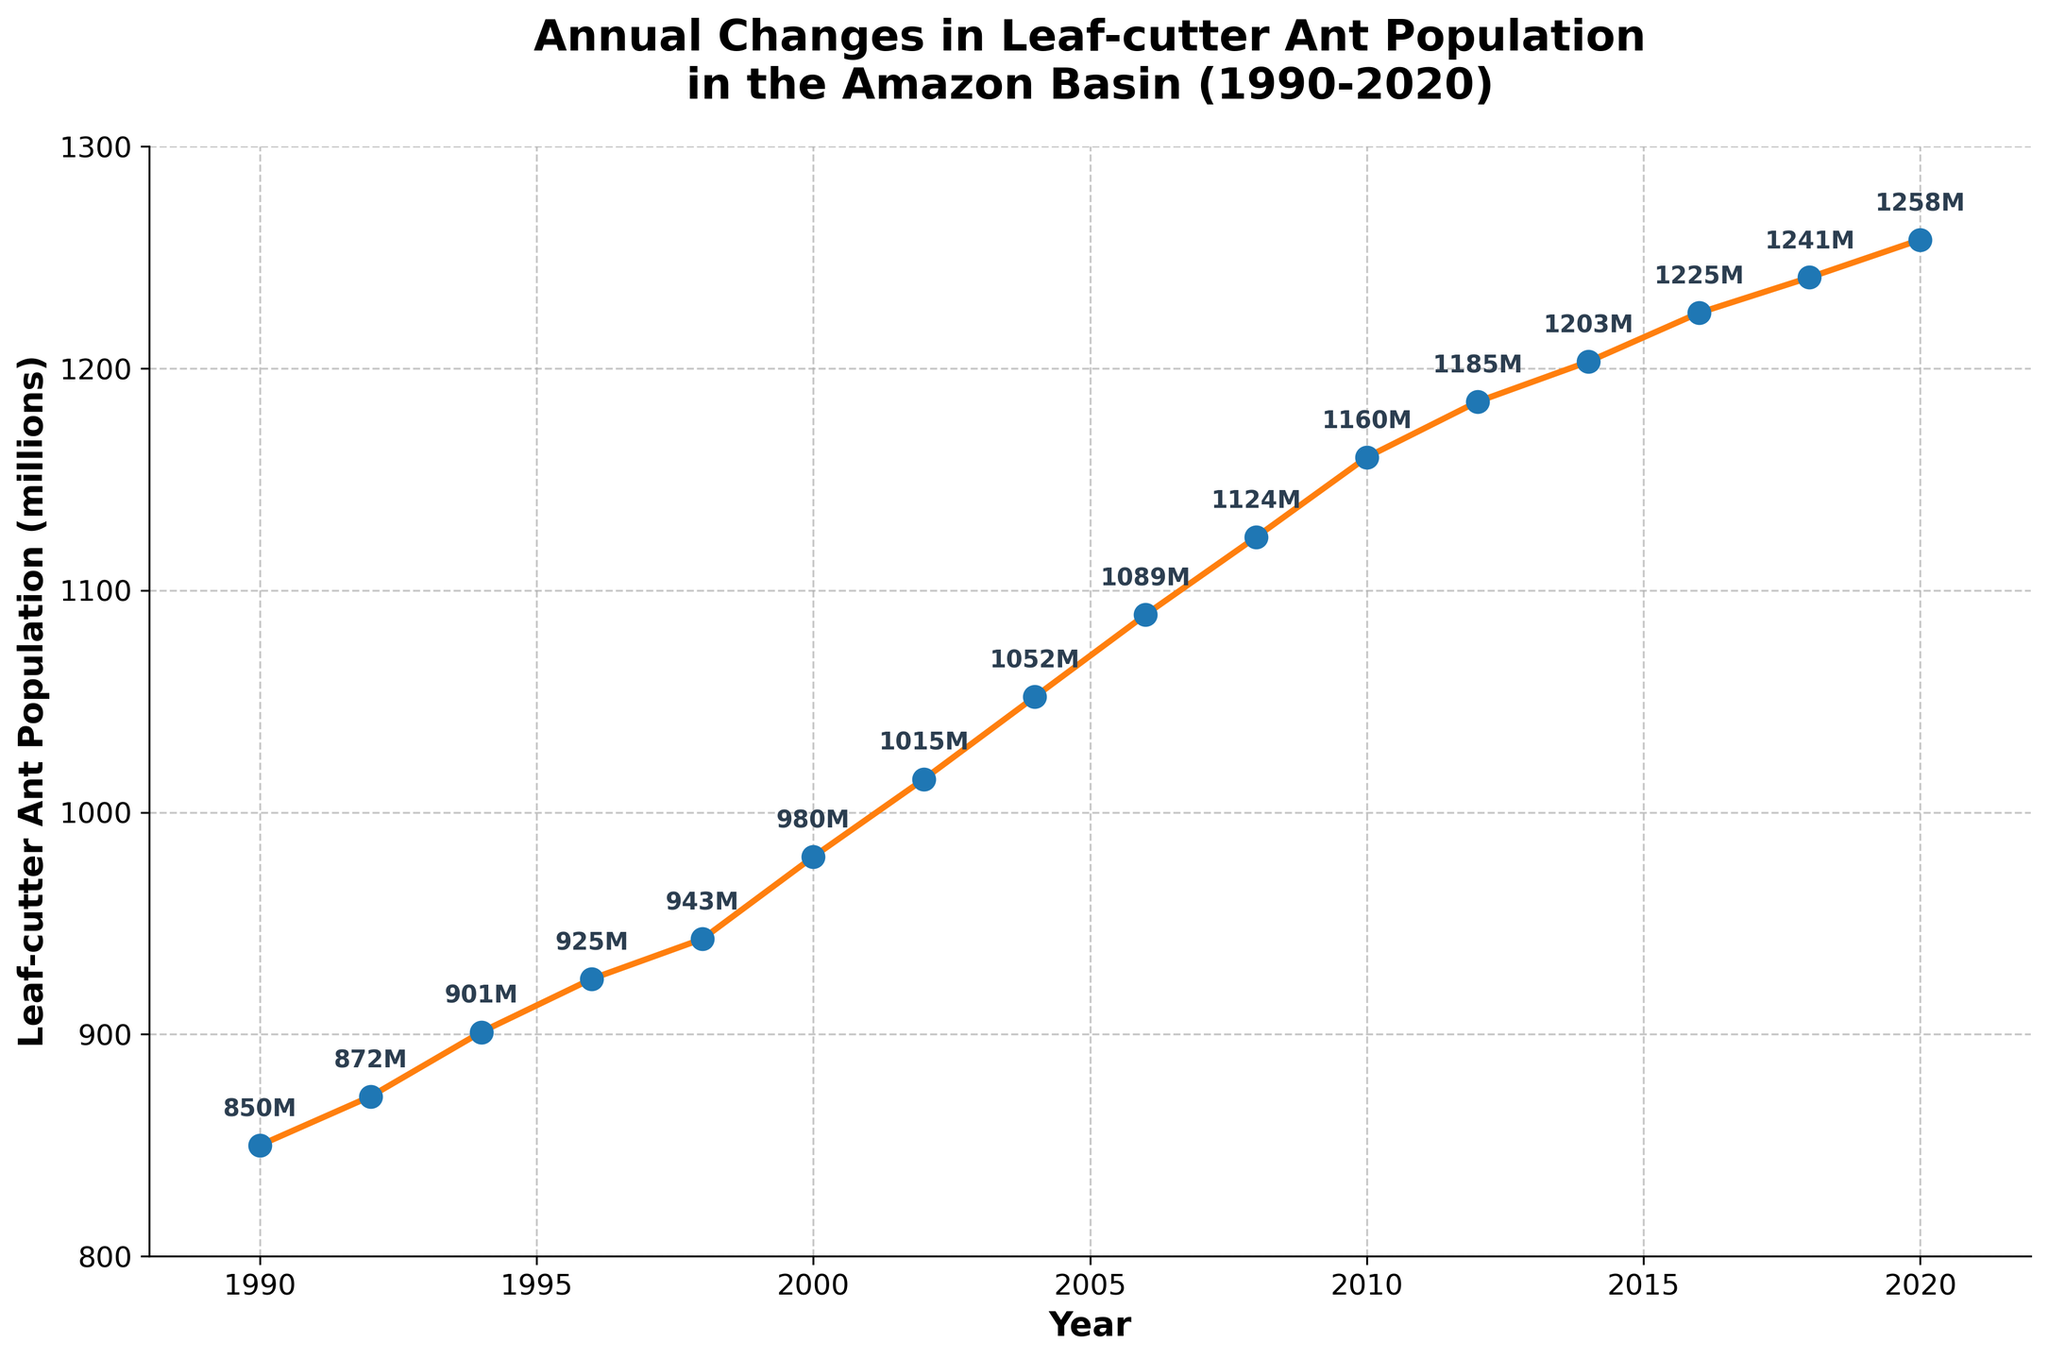What trend is visible in the population of leaf-cutter ants from 1990 to 2020? The plot shows a consistent increase in the population of leaf-cutter ants from 1990, where it was at 850 million, to 2020, where it reached 1258 million. This indicates a steady growth over the 30-year period.
Answer: Steady increase How much did the population of leaf-cutter ants grow from 1990 to 2000? In 1990, the population was 850 million. In 2000, it was 980 million. The difference between these two values is 980 - 850 = 130 million.
Answer: 130 million What is the average annual population growth rate of leaf-cutter ants between 2000 and 2020? The population in 2000 was 980 million and in 2020, it was 1258 million. The growth over these 20 years is 1258 - 980 = 278 million. The average annual growth rate is 278 / 20 = 13.9 million per year.
Answer: 13.9 million per year In which year did the leaf-cutter ant population first exceed 1000 million? By examining the plot, we can see that the population exceeds 1000 million between 2000 (980 million) and 2002 (1015 million), so 2002 is the first year it surpassed this mark.
Answer: 2002 Between which consecutive years was the largest increase in the population of leaf-cutter ants observed? Analyzing the increments shown in the plot, the largest population increase was between 1998 (943 million) and 2000 (980 million), which is an increase of 37 million.
Answer: 1998 to 2000 How does the population change between 1990 and 2020 compare to the change between 2000 and 2020? From 1990 to 2020, the population increased from 850 to 1258 million, a change of 408 million. From 2000 to 2020, it increased from 980 to 1258 million, a change of 278 million. Thus, the change from 1990 to 2020 is greater.
Answer: 1990 to 2020 has a greater increase What is the median population value of leaf-cutter ants in the plot? The data points are: 850, 872, 901, 925, 943, 980, 1015, 1052, 1089, 1124, 1160, 1185, 1203, 1225, 1241, 1258. There are 16 values, so the median is the average of the 8th and 9th values (1052 and 1089), which is (1052 + 1089) / 2 = 1070.5
Answer: 1070.5 Does the population growth rate of leaf-cutter ants appear to be linear or exponential? The plot shows a gradually increasing population, but not at a constant rate. The line has a slightly upward curve, indicating a growth pattern that is more exponential than linear.
Answer: Exponential Which year saw the smallest increase in the population size of leaf-cutter ants? By looking at the plot's annotation for each year, we see the smallest increase occurred from 2012 (1185 million) to 2014 (1203 million), with an increase of only 18 million.
Answer: 2012 to 2014 